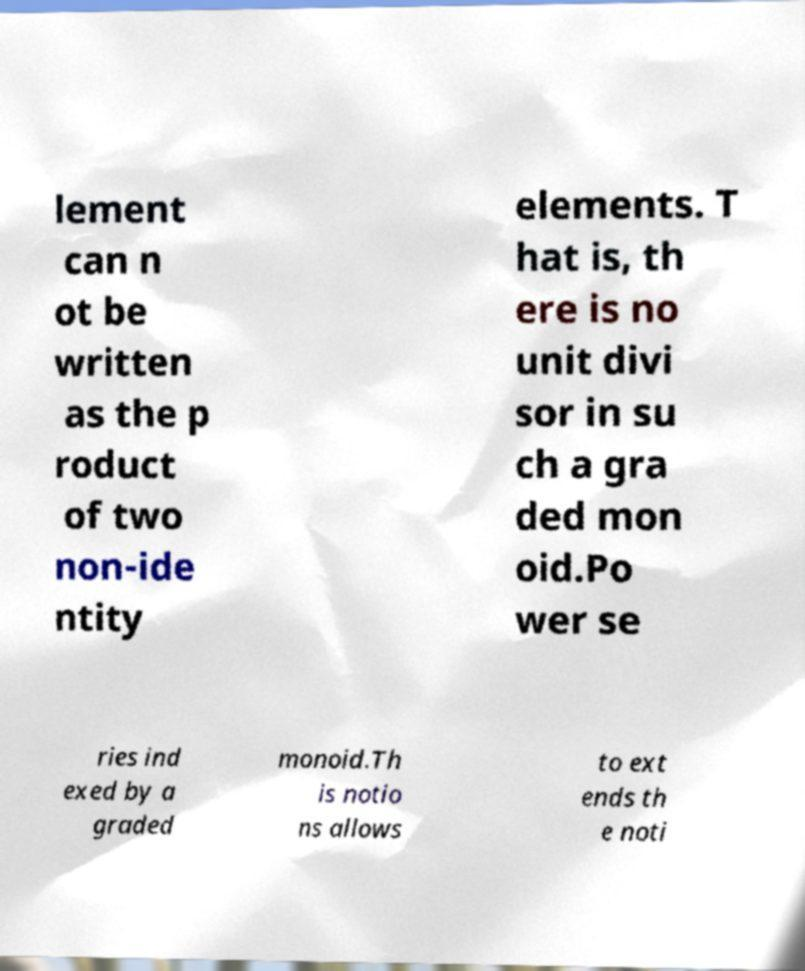Please read and relay the text visible in this image. What does it say? lement can n ot be written as the p roduct of two non-ide ntity elements. T hat is, th ere is no unit divi sor in su ch a gra ded mon oid.Po wer se ries ind exed by a graded monoid.Th is notio ns allows to ext ends th e noti 